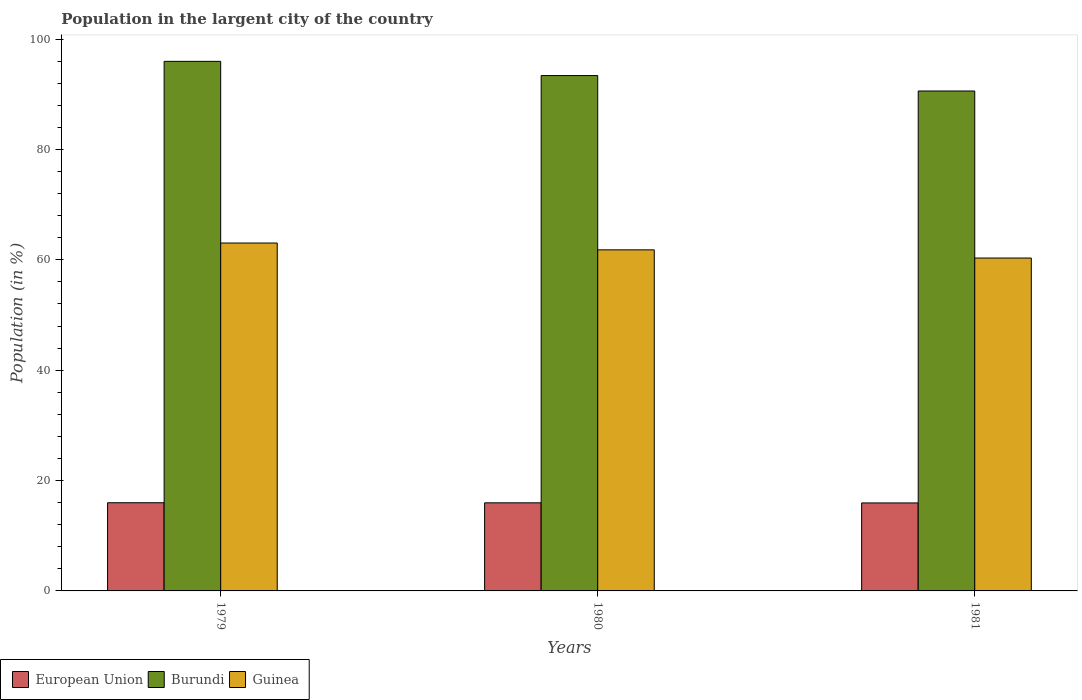Are the number of bars per tick equal to the number of legend labels?
Offer a terse response. Yes. Are the number of bars on each tick of the X-axis equal?
Your response must be concise. Yes. How many bars are there on the 1st tick from the left?
Your response must be concise. 3. In how many cases, is the number of bars for a given year not equal to the number of legend labels?
Offer a very short reply. 0. What is the percentage of population in the largent city in Guinea in 1979?
Offer a very short reply. 63.04. Across all years, what is the maximum percentage of population in the largent city in Guinea?
Give a very brief answer. 63.04. Across all years, what is the minimum percentage of population in the largent city in European Union?
Keep it short and to the point. 15.94. In which year was the percentage of population in the largent city in Burundi maximum?
Your answer should be very brief. 1979. What is the total percentage of population in the largent city in Burundi in the graph?
Your answer should be compact. 279.94. What is the difference between the percentage of population in the largent city in Guinea in 1979 and that in 1981?
Your response must be concise. 2.72. What is the difference between the percentage of population in the largent city in Burundi in 1979 and the percentage of population in the largent city in European Union in 1980?
Keep it short and to the point. 80. What is the average percentage of population in the largent city in Guinea per year?
Your response must be concise. 61.72. In the year 1981, what is the difference between the percentage of population in the largent city in Guinea and percentage of population in the largent city in European Union?
Keep it short and to the point. 44.38. In how many years, is the percentage of population in the largent city in Guinea greater than 24 %?
Make the answer very short. 3. What is the ratio of the percentage of population in the largent city in Guinea in 1979 to that in 1980?
Offer a terse response. 1.02. Is the percentage of population in the largent city in Guinea in 1980 less than that in 1981?
Ensure brevity in your answer.  No. What is the difference between the highest and the second highest percentage of population in the largent city in Guinea?
Give a very brief answer. 1.24. What is the difference between the highest and the lowest percentage of population in the largent city in Guinea?
Your answer should be very brief. 2.72. In how many years, is the percentage of population in the largent city in Burundi greater than the average percentage of population in the largent city in Burundi taken over all years?
Give a very brief answer. 2. Is the sum of the percentage of population in the largent city in European Union in 1979 and 1981 greater than the maximum percentage of population in the largent city in Burundi across all years?
Ensure brevity in your answer.  No. What does the 3rd bar from the right in 1979 represents?
Keep it short and to the point. European Union. How many bars are there?
Provide a succinct answer. 9. What is the difference between two consecutive major ticks on the Y-axis?
Your answer should be compact. 20. Where does the legend appear in the graph?
Keep it short and to the point. Bottom left. How many legend labels are there?
Make the answer very short. 3. How are the legend labels stacked?
Offer a very short reply. Horizontal. What is the title of the graph?
Your answer should be compact. Population in the largent city of the country. What is the label or title of the X-axis?
Keep it short and to the point. Years. What is the label or title of the Y-axis?
Ensure brevity in your answer.  Population (in %). What is the Population (in %) in European Union in 1979?
Keep it short and to the point. 15.98. What is the Population (in %) of Burundi in 1979?
Make the answer very short. 95.96. What is the Population (in %) in Guinea in 1979?
Offer a terse response. 63.04. What is the Population (in %) in European Union in 1980?
Your response must be concise. 15.97. What is the Population (in %) in Burundi in 1980?
Offer a very short reply. 93.39. What is the Population (in %) in Guinea in 1980?
Offer a very short reply. 61.8. What is the Population (in %) of European Union in 1981?
Your response must be concise. 15.94. What is the Population (in %) in Burundi in 1981?
Ensure brevity in your answer.  90.59. What is the Population (in %) of Guinea in 1981?
Your answer should be very brief. 60.32. Across all years, what is the maximum Population (in %) in European Union?
Your response must be concise. 15.98. Across all years, what is the maximum Population (in %) of Burundi?
Give a very brief answer. 95.96. Across all years, what is the maximum Population (in %) in Guinea?
Give a very brief answer. 63.04. Across all years, what is the minimum Population (in %) in European Union?
Provide a short and direct response. 15.94. Across all years, what is the minimum Population (in %) in Burundi?
Your answer should be very brief. 90.59. Across all years, what is the minimum Population (in %) in Guinea?
Provide a succinct answer. 60.32. What is the total Population (in %) in European Union in the graph?
Provide a succinct answer. 47.89. What is the total Population (in %) in Burundi in the graph?
Give a very brief answer. 279.94. What is the total Population (in %) in Guinea in the graph?
Your answer should be compact. 185.17. What is the difference between the Population (in %) in European Union in 1979 and that in 1980?
Your response must be concise. 0.01. What is the difference between the Population (in %) in Burundi in 1979 and that in 1980?
Make the answer very short. 2.58. What is the difference between the Population (in %) in Guinea in 1979 and that in 1980?
Your answer should be very brief. 1.24. What is the difference between the Population (in %) in European Union in 1979 and that in 1981?
Provide a succinct answer. 0.04. What is the difference between the Population (in %) of Burundi in 1979 and that in 1981?
Provide a short and direct response. 5.37. What is the difference between the Population (in %) in Guinea in 1979 and that in 1981?
Provide a succinct answer. 2.72. What is the difference between the Population (in %) in European Union in 1980 and that in 1981?
Ensure brevity in your answer.  0.02. What is the difference between the Population (in %) in Burundi in 1980 and that in 1981?
Make the answer very short. 2.8. What is the difference between the Population (in %) of Guinea in 1980 and that in 1981?
Provide a succinct answer. 1.48. What is the difference between the Population (in %) in European Union in 1979 and the Population (in %) in Burundi in 1980?
Ensure brevity in your answer.  -77.41. What is the difference between the Population (in %) of European Union in 1979 and the Population (in %) of Guinea in 1980?
Offer a very short reply. -45.82. What is the difference between the Population (in %) of Burundi in 1979 and the Population (in %) of Guinea in 1980?
Provide a succinct answer. 34.16. What is the difference between the Population (in %) in European Union in 1979 and the Population (in %) in Burundi in 1981?
Provide a short and direct response. -74.61. What is the difference between the Population (in %) of European Union in 1979 and the Population (in %) of Guinea in 1981?
Your answer should be very brief. -44.34. What is the difference between the Population (in %) of Burundi in 1979 and the Population (in %) of Guinea in 1981?
Provide a short and direct response. 35.64. What is the difference between the Population (in %) in European Union in 1980 and the Population (in %) in Burundi in 1981?
Provide a short and direct response. -74.63. What is the difference between the Population (in %) in European Union in 1980 and the Population (in %) in Guinea in 1981?
Your answer should be compact. -44.36. What is the difference between the Population (in %) in Burundi in 1980 and the Population (in %) in Guinea in 1981?
Provide a short and direct response. 33.06. What is the average Population (in %) of European Union per year?
Offer a very short reply. 15.96. What is the average Population (in %) in Burundi per year?
Ensure brevity in your answer.  93.31. What is the average Population (in %) of Guinea per year?
Provide a succinct answer. 61.72. In the year 1979, what is the difference between the Population (in %) of European Union and Population (in %) of Burundi?
Offer a terse response. -79.98. In the year 1979, what is the difference between the Population (in %) in European Union and Population (in %) in Guinea?
Offer a very short reply. -47.06. In the year 1979, what is the difference between the Population (in %) of Burundi and Population (in %) of Guinea?
Your answer should be compact. 32.92. In the year 1980, what is the difference between the Population (in %) of European Union and Population (in %) of Burundi?
Your response must be concise. -77.42. In the year 1980, what is the difference between the Population (in %) in European Union and Population (in %) in Guinea?
Offer a terse response. -45.84. In the year 1980, what is the difference between the Population (in %) in Burundi and Population (in %) in Guinea?
Give a very brief answer. 31.58. In the year 1981, what is the difference between the Population (in %) of European Union and Population (in %) of Burundi?
Ensure brevity in your answer.  -74.65. In the year 1981, what is the difference between the Population (in %) of European Union and Population (in %) of Guinea?
Ensure brevity in your answer.  -44.38. In the year 1981, what is the difference between the Population (in %) of Burundi and Population (in %) of Guinea?
Keep it short and to the point. 30.27. What is the ratio of the Population (in %) of Burundi in 1979 to that in 1980?
Offer a terse response. 1.03. What is the ratio of the Population (in %) of Guinea in 1979 to that in 1980?
Give a very brief answer. 1.02. What is the ratio of the Population (in %) in Burundi in 1979 to that in 1981?
Make the answer very short. 1.06. What is the ratio of the Population (in %) in Guinea in 1979 to that in 1981?
Offer a terse response. 1.05. What is the ratio of the Population (in %) of European Union in 1980 to that in 1981?
Provide a short and direct response. 1. What is the ratio of the Population (in %) of Burundi in 1980 to that in 1981?
Provide a short and direct response. 1.03. What is the ratio of the Population (in %) of Guinea in 1980 to that in 1981?
Make the answer very short. 1.02. What is the difference between the highest and the second highest Population (in %) in European Union?
Your answer should be compact. 0.01. What is the difference between the highest and the second highest Population (in %) of Burundi?
Offer a terse response. 2.58. What is the difference between the highest and the second highest Population (in %) of Guinea?
Offer a very short reply. 1.24. What is the difference between the highest and the lowest Population (in %) in European Union?
Keep it short and to the point. 0.04. What is the difference between the highest and the lowest Population (in %) of Burundi?
Make the answer very short. 5.37. What is the difference between the highest and the lowest Population (in %) of Guinea?
Your response must be concise. 2.72. 